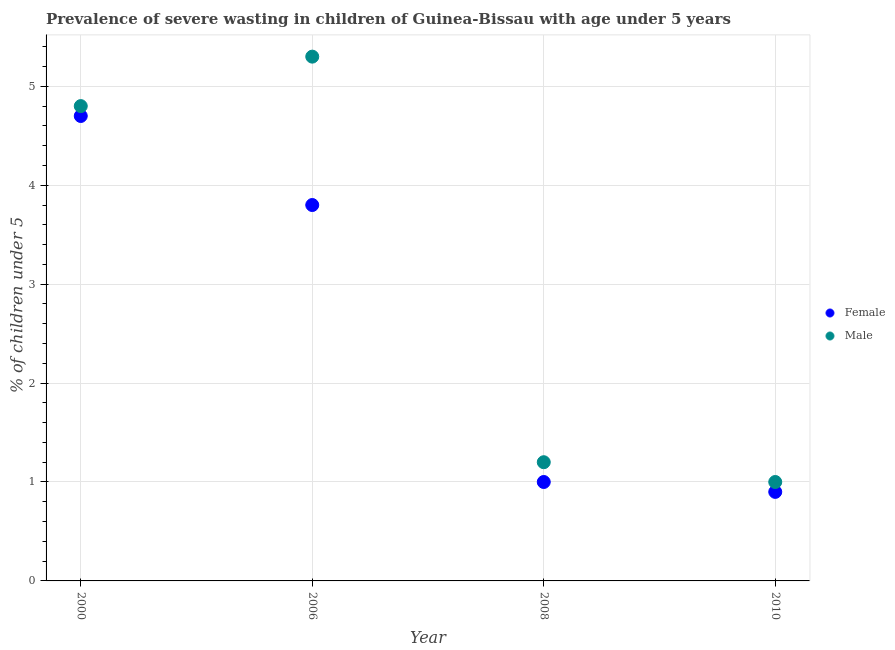How many different coloured dotlines are there?
Ensure brevity in your answer.  2. What is the percentage of undernourished male children in 2006?
Provide a short and direct response. 5.3. Across all years, what is the maximum percentage of undernourished male children?
Give a very brief answer. 5.3. In which year was the percentage of undernourished male children maximum?
Keep it short and to the point. 2006. What is the total percentage of undernourished male children in the graph?
Your answer should be very brief. 12.3. What is the difference between the percentage of undernourished male children in 2000 and that in 2008?
Provide a short and direct response. 3.6. What is the difference between the percentage of undernourished female children in 2010 and the percentage of undernourished male children in 2000?
Provide a short and direct response. -3.9. What is the average percentage of undernourished male children per year?
Offer a very short reply. 3.08. In the year 2006, what is the difference between the percentage of undernourished female children and percentage of undernourished male children?
Keep it short and to the point. -1.5. In how many years, is the percentage of undernourished male children greater than 2.4 %?
Keep it short and to the point. 2. What is the ratio of the percentage of undernourished male children in 2006 to that in 2008?
Your response must be concise. 4.42. Is the percentage of undernourished female children in 2006 less than that in 2008?
Offer a terse response. No. Is the difference between the percentage of undernourished female children in 2000 and 2006 greater than the difference between the percentage of undernourished male children in 2000 and 2006?
Give a very brief answer. Yes. What is the difference between the highest and the second highest percentage of undernourished male children?
Offer a terse response. 0.5. What is the difference between the highest and the lowest percentage of undernourished female children?
Give a very brief answer. 3.8. In how many years, is the percentage of undernourished male children greater than the average percentage of undernourished male children taken over all years?
Offer a terse response. 2. Is the sum of the percentage of undernourished female children in 2000 and 2006 greater than the maximum percentage of undernourished male children across all years?
Give a very brief answer. Yes. What is the difference between two consecutive major ticks on the Y-axis?
Your answer should be compact. 1. Where does the legend appear in the graph?
Your response must be concise. Center right. How are the legend labels stacked?
Give a very brief answer. Vertical. What is the title of the graph?
Provide a succinct answer. Prevalence of severe wasting in children of Guinea-Bissau with age under 5 years. What is the label or title of the Y-axis?
Provide a succinct answer.  % of children under 5. What is the  % of children under 5 in Female in 2000?
Make the answer very short. 4.7. What is the  % of children under 5 of Male in 2000?
Provide a short and direct response. 4.8. What is the  % of children under 5 of Female in 2006?
Provide a succinct answer. 3.8. What is the  % of children under 5 in Male in 2006?
Ensure brevity in your answer.  5.3. What is the  % of children under 5 in Female in 2008?
Your answer should be compact. 1. What is the  % of children under 5 in Male in 2008?
Your answer should be compact. 1.2. What is the  % of children under 5 in Female in 2010?
Your answer should be very brief. 0.9. What is the  % of children under 5 of Male in 2010?
Make the answer very short. 1. Across all years, what is the maximum  % of children under 5 in Female?
Offer a terse response. 4.7. Across all years, what is the maximum  % of children under 5 in Male?
Provide a short and direct response. 5.3. Across all years, what is the minimum  % of children under 5 in Female?
Offer a terse response. 0.9. What is the total  % of children under 5 of Male in the graph?
Keep it short and to the point. 12.3. What is the difference between the  % of children under 5 in Male in 2000 and that in 2006?
Your answer should be compact. -0.5. What is the difference between the  % of children under 5 in Female in 2000 and that in 2008?
Your answer should be compact. 3.7. What is the difference between the  % of children under 5 in Male in 2000 and that in 2008?
Give a very brief answer. 3.6. What is the difference between the  % of children under 5 in Male in 2006 and that in 2008?
Ensure brevity in your answer.  4.1. What is the difference between the  % of children under 5 of Male in 2008 and that in 2010?
Keep it short and to the point. 0.2. What is the difference between the  % of children under 5 in Female in 2000 and the  % of children under 5 in Male in 2006?
Make the answer very short. -0.6. What is the difference between the  % of children under 5 of Female in 2000 and the  % of children under 5 of Male in 2010?
Provide a succinct answer. 3.7. What is the difference between the  % of children under 5 in Female in 2008 and the  % of children under 5 in Male in 2010?
Keep it short and to the point. 0. What is the average  % of children under 5 of Female per year?
Offer a terse response. 2.6. What is the average  % of children under 5 of Male per year?
Your answer should be compact. 3.08. In the year 2006, what is the difference between the  % of children under 5 in Female and  % of children under 5 in Male?
Your response must be concise. -1.5. What is the ratio of the  % of children under 5 in Female in 2000 to that in 2006?
Offer a very short reply. 1.24. What is the ratio of the  % of children under 5 of Male in 2000 to that in 2006?
Offer a terse response. 0.91. What is the ratio of the  % of children under 5 in Female in 2000 to that in 2008?
Keep it short and to the point. 4.7. What is the ratio of the  % of children under 5 in Female in 2000 to that in 2010?
Give a very brief answer. 5.22. What is the ratio of the  % of children under 5 of Male in 2000 to that in 2010?
Ensure brevity in your answer.  4.8. What is the ratio of the  % of children under 5 of Female in 2006 to that in 2008?
Provide a short and direct response. 3.8. What is the ratio of the  % of children under 5 in Male in 2006 to that in 2008?
Keep it short and to the point. 4.42. What is the ratio of the  % of children under 5 of Female in 2006 to that in 2010?
Provide a succinct answer. 4.22. What is the ratio of the  % of children under 5 in Male in 2006 to that in 2010?
Your response must be concise. 5.3. What is the ratio of the  % of children under 5 of Male in 2008 to that in 2010?
Give a very brief answer. 1.2. 